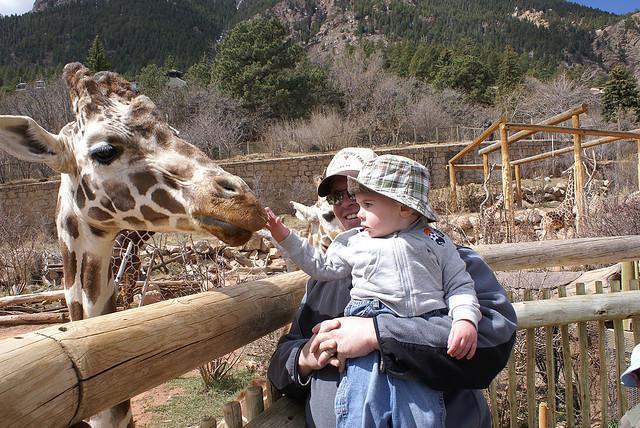How many people wearing hats?
Give a very brief answer. 2. How many people are there?
Give a very brief answer. 2. How many things is the man with the tie holding?
Give a very brief answer. 0. 